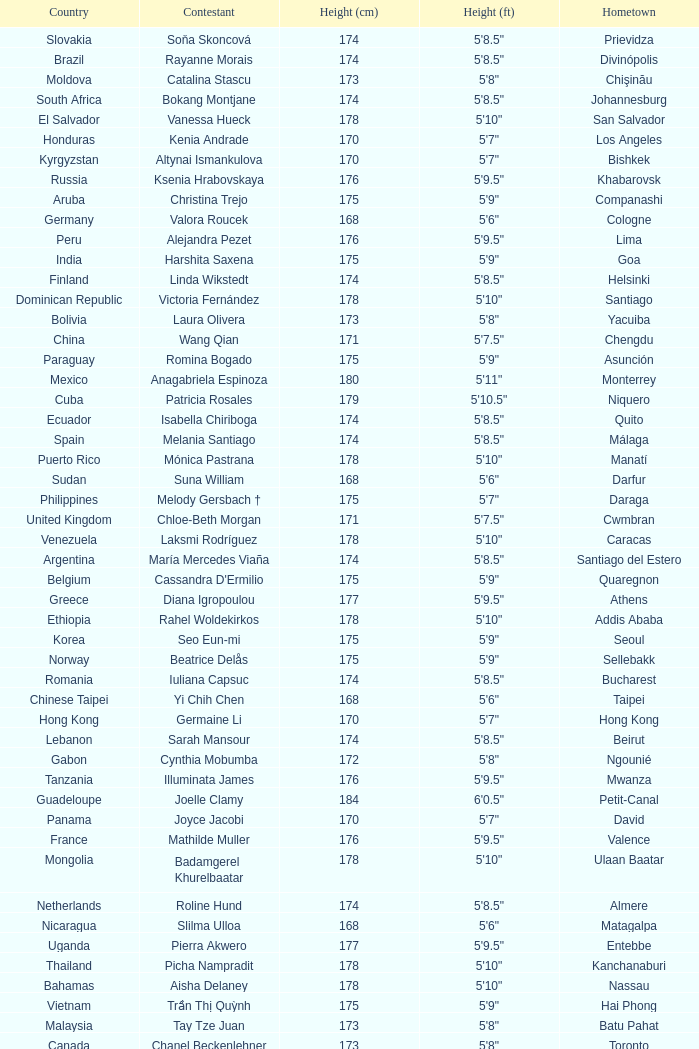Give me the full table as a dictionary. {'header': ['Country', 'Contestant', 'Height (cm)', 'Height (ft)', 'Hometown'], 'rows': [['Slovakia', 'Soňa Skoncová', '174', '5\'8.5"', 'Prievidza'], ['Brazil', 'Rayanne Morais', '174', '5\'8.5"', 'Divinópolis'], ['Moldova', 'Catalina Stascu', '173', '5\'8"', 'Chişinău'], ['South Africa', 'Bokang Montjane', '174', '5\'8.5"', 'Johannesburg'], ['El Salvador', 'Vanessa Hueck', '178', '5\'10"', 'San Salvador'], ['Honduras', 'Kenia Andrade', '170', '5\'7"', 'Los Angeles'], ['Kyrgyzstan', 'Altynai Ismankulova', '170', '5\'7"', 'Bishkek'], ['Russia', 'Ksenia Hrabovskaya', '176', '5\'9.5"', 'Khabarovsk'], ['Aruba', 'Christina Trejo', '175', '5\'9"', 'Companashi'], ['Germany', 'Valora Roucek', '168', '5\'6"', 'Cologne'], ['Peru', 'Alejandra Pezet', '176', '5\'9.5"', 'Lima'], ['India', 'Harshita Saxena', '175', '5\'9"', 'Goa'], ['Finland', 'Linda Wikstedt', '174', '5\'8.5"', 'Helsinki'], ['Dominican Republic', 'Victoria Fernández', '178', '5\'10"', 'Santiago'], ['Bolivia', 'Laura Olivera', '173', '5\'8"', 'Yacuiba'], ['China', 'Wang Qian', '171', '5\'7.5"', 'Chengdu'], ['Paraguay', 'Romina Bogado', '175', '5\'9"', 'Asunción'], ['Mexico', 'Anagabriela Espinoza', '180', '5\'11"', 'Monterrey'], ['Cuba', 'Patricia Rosales', '179', '5\'10.5"', 'Niquero'], ['Ecuador', 'Isabella Chiriboga', '174', '5\'8.5"', 'Quito'], ['Spain', 'Melania Santiago', '174', '5\'8.5"', 'Málaga'], ['Puerto Rico', 'Mónica Pastrana', '178', '5\'10"', 'Manatí'], ['Sudan', 'Suna William', '168', '5\'6"', 'Darfur'], ['Philippines', 'Melody Gersbach †', '175', '5\'7"', 'Daraga'], ['United Kingdom', 'Chloe-Beth Morgan', '171', '5\'7.5"', 'Cwmbran'], ['Venezuela', 'Laksmi Rodríguez', '178', '5\'10"', 'Caracas'], ['Argentina', 'María Mercedes Viaña', '174', '5\'8.5"', 'Santiago del Estero'], ['Belgium', "Cassandra D'Ermilio", '175', '5\'9"', 'Quaregnon'], ['Greece', 'Diana Igropoulou', '177', '5\'9.5"', 'Athens'], ['Ethiopia', 'Rahel Woldekirkos', '178', '5\'10"', 'Addis Ababa'], ['Korea', 'Seo Eun-mi', '175', '5\'9"', 'Seoul'], ['Norway', 'Beatrice Delås', '175', '5\'9"', 'Sellebakk'], ['Romania', 'Iuliana Capsuc', '174', '5\'8.5"', 'Bucharest'], ['Chinese Taipei', 'Yi Chih Chen', '168', '5\'6"', 'Taipei'], ['Hong Kong', 'Germaine Li', '170', '5\'7"', 'Hong Kong'], ['Lebanon', 'Sarah Mansour', '174', '5\'8.5"', 'Beirut'], ['Gabon', 'Cynthia Mobumba', '172', '5\'8"', 'Ngounié'], ['Tanzania', 'Illuminata James', '176', '5\'9.5"', 'Mwanza'], ['Guadeloupe', 'Joelle Clamy', '184', '6\'0.5"', 'Petit-Canal'], ['Panama', 'Joyce Jacobi', '170', '5\'7"', 'David'], ['France', 'Mathilde Muller', '176', '5\'9.5"', 'Valence'], ['Mongolia', 'Badamgerel Khurelbaatar', '178', '5\'10"', 'Ulaan Baatar'], ['Netherlands', 'Roline Hund', '174', '5\'8.5"', 'Almere'], ['Nicaragua', 'Slilma Ulloa', '168', '5\'6"', 'Matagalpa'], ['Uganda', 'Pierra Akwero', '177', '5\'9.5"', 'Entebbe'], ['Thailand', 'Picha Nampradit', '178', '5\'10"', 'Kanchanaburi'], ['Bahamas', 'Aisha Delaney', '178', '5\'10"', 'Nassau'], ['Vietnam', 'Trần Thị Quỳnh', '175', '5\'9"', 'Hai Phong'], ['Malaysia', 'Tay Tze Juan', '173', '5\'8"', 'Batu Pahat'], ['Canada', 'Chanel Beckenlehner', '173', '5\'8"', 'Toronto'], ['Macau', 'Yvonne Yang', '179', '5\'10.5"', 'Macau'], ['Martinique', 'Nathaly Peters', '175', '5\'9"', 'Fort de France'], ['USA', 'Aileen Jan Yap', '170', '5\'6"', 'Houston'], ['Latvia', 'Anda Pudule', '173', '5\'8"', 'Riga'], ['Australia', 'Kelly Louise Macguire', '174', '5\'8.5"', 'Sydney'], ['Indonesia', 'Ayu Diandra Sari', '175', '5\'9"', 'Denpasar'], ['Japan', 'Yuka Nakayama', '173', '5\'8"', 'Fukuoka'], ['Singapore', 'Annabelle Liang', '169', '5\'6.5"', 'Singapore'], ['Colombia', 'Lina Mosquera', '180', '5\'11"', 'Quibdó'], ['Northern Marianas', 'Sorene Maratita', '163', '5\'4"', 'Saipan'], ['Belarus', 'Yana Supranovich', '180', '5\'11"', 'Minsk'], ['Turkey', 'Begüm Yılmaz', '180', '5\'11"', 'Izmir'], ['Poland', 'Angelika Jakubowska', '176', '5\'9.5"', 'Lubań'], ['Georgia', 'Maria Sarchimelia', '174', '5\'8.5"', 'Tbilisi'], ['Czech Republic', 'Darja Jacukevičová', '180', '5\'11"', 'Veselí nad Moravou']]} What is the hometown of the player from Indonesia? Denpasar. 